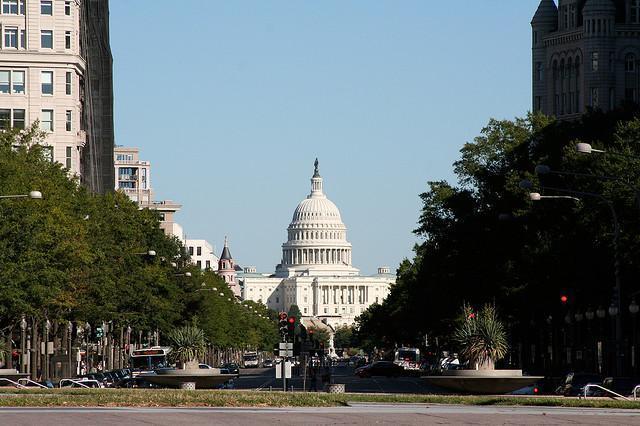How many large bags is the old man holding?
Give a very brief answer. 0. 